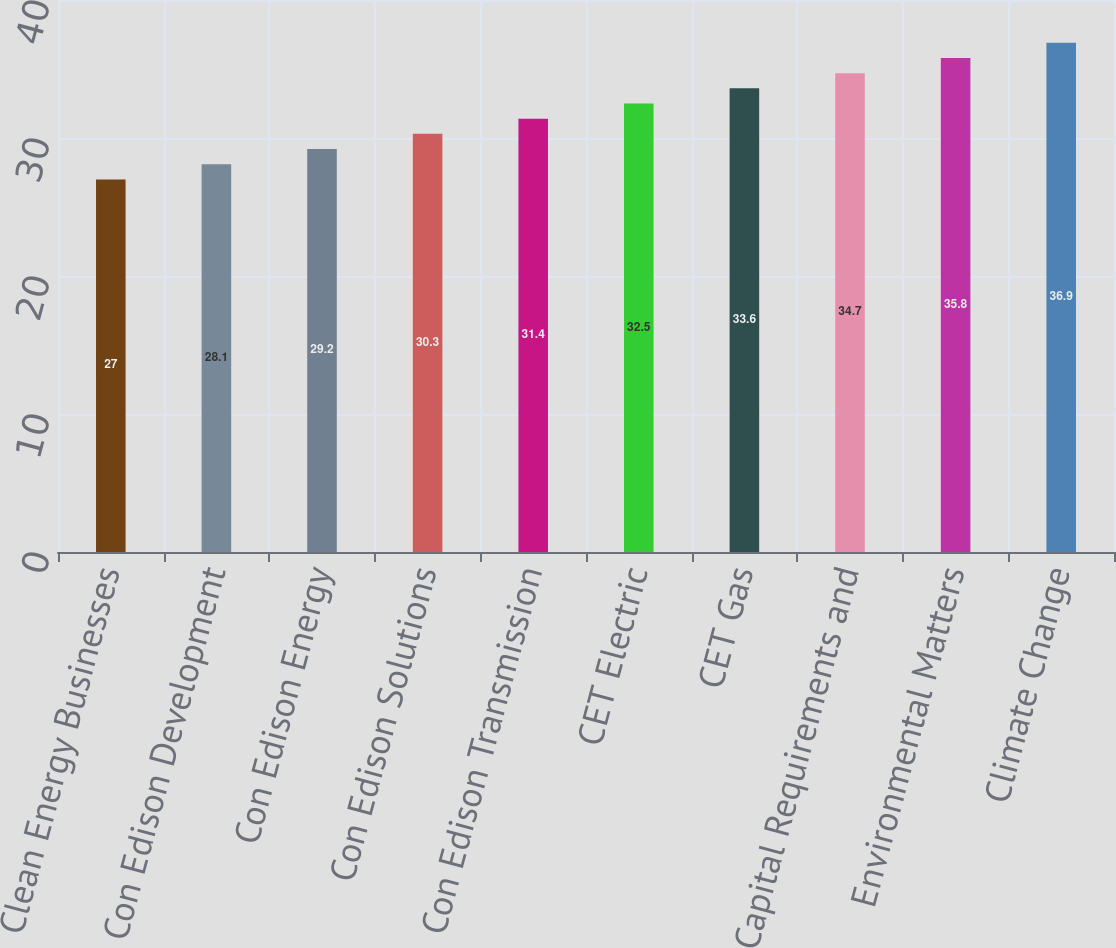Convert chart. <chart><loc_0><loc_0><loc_500><loc_500><bar_chart><fcel>Clean Energy Businesses<fcel>Con Edison Development<fcel>Con Edison Energy<fcel>Con Edison Solutions<fcel>Con Edison Transmission<fcel>CET Electric<fcel>CET Gas<fcel>Capital Requirements and<fcel>Environmental Matters<fcel>Climate Change<nl><fcel>27<fcel>28.1<fcel>29.2<fcel>30.3<fcel>31.4<fcel>32.5<fcel>33.6<fcel>34.7<fcel>35.8<fcel>36.9<nl></chart> 